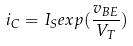<formula> <loc_0><loc_0><loc_500><loc_500>i _ { C } = I _ { S } e x p ( \frac { v _ { B E } } { V _ { T } } )</formula> 